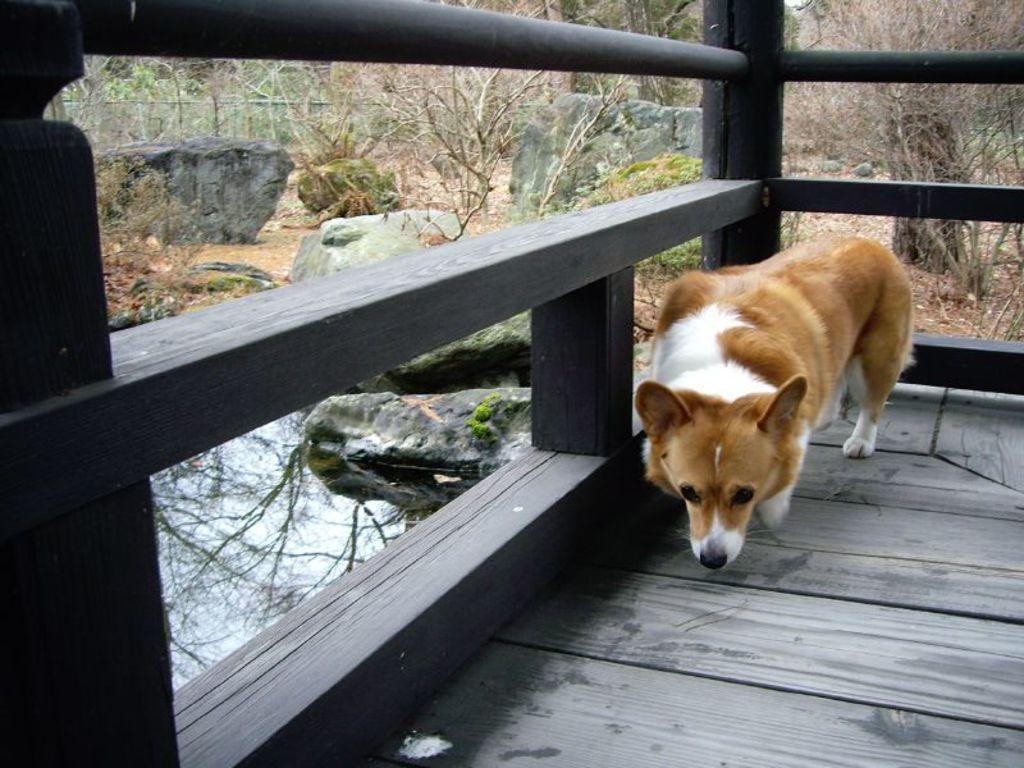Describe this image in one or two sentences. In this image there is a dog on a wooden surface, there is a wooden fencing truncated, there are rocks, there are trees truncated towards the top of the image, there are trees truncated towards the right of the image, there is water. 